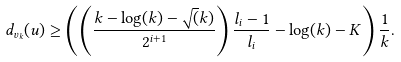<formula> <loc_0><loc_0><loc_500><loc_500>d _ { v _ { k } } ( u ) \geq \left ( \left ( \frac { k - \log ( k ) - \sqrt { ( } k ) } { 2 ^ { i + 1 } } \right ) \frac { l _ { i } - 1 } { l _ { i } } - \log ( k ) - K \right ) \frac { 1 } { k } .</formula> 